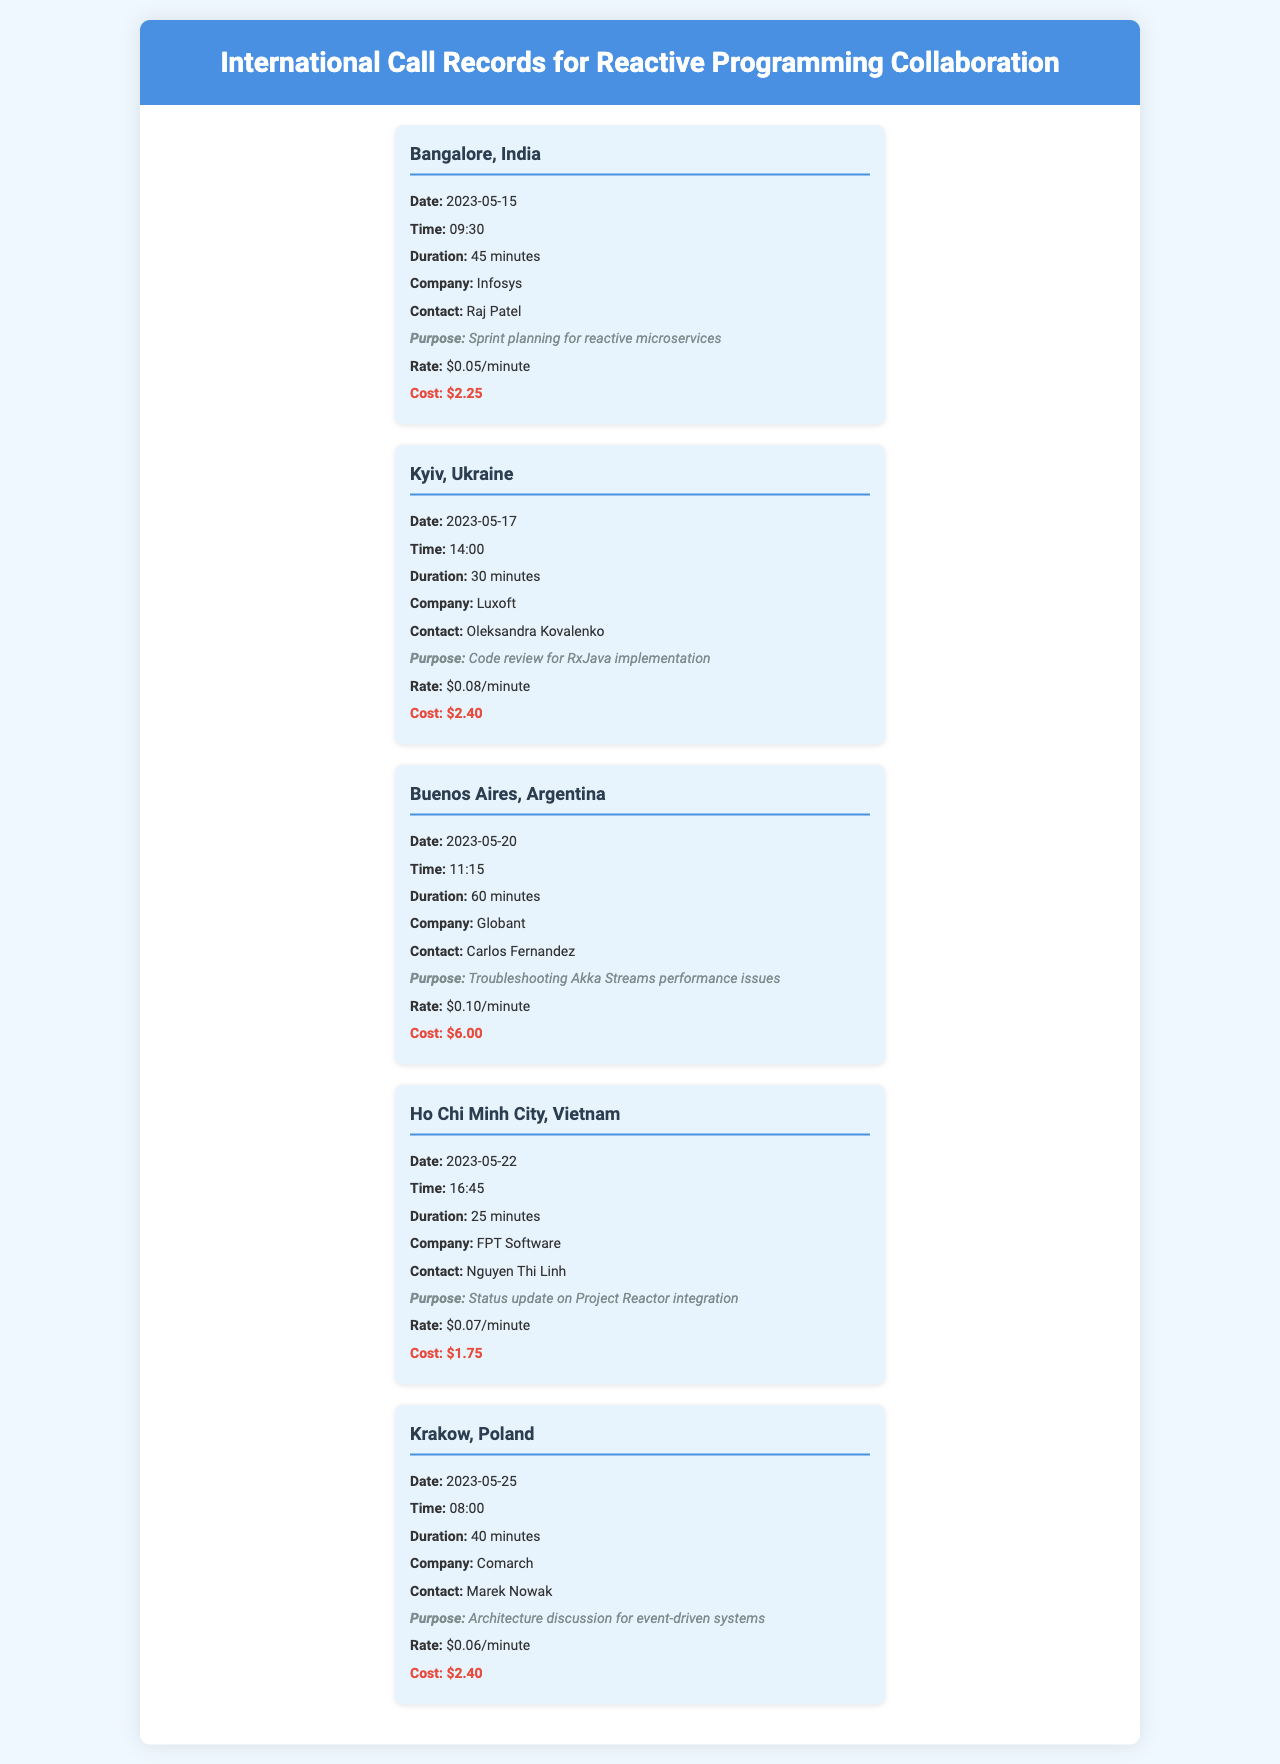What was the purpose of the call to Bangalore? The purpose listed for the Bangalore call is "Sprint planning for reactive microservices."
Answer: Sprint planning for reactive microservices What was the duration of the call to Kyiv? The document states the duration of the Kyiv call is "30 minutes."
Answer: 30 minutes What was the cost of the call to Buenos Aires? The cost for the Buenos Aires call is mentioned as "$6.00."
Answer: $6.00 Which company's contact was discussed during the call to Krakow? The call to Krakow involved the company "Comarch."
Answer: Comarch What rate per minute was charged for the call to Ho Chi Minh City? The rate for the Ho Chi Minh City call is "$0.07/minute."
Answer: $0.07/minute Which country had the highest call cost? The call to Buenos Aires had the highest cost at "$6.00."
Answer: Buenos Aires How many calls were made for troubleshooting purposes? There was one call made for troubleshooting purposes, specifically to Buenos Aires.
Answer: One What was the time of the call to Bangalore? The specified time for the Bangalore call is "09:30."
Answer: 09:30 Which city had a call discussing architecture? The city mentioned for the architecture discussion is "Krakow."
Answer: Krakow 